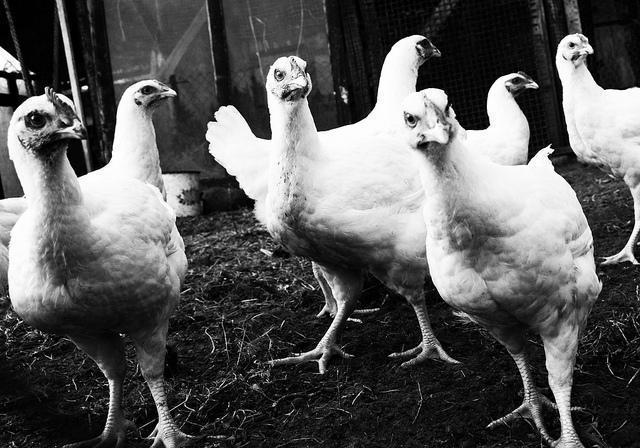What type of animal is in the image?
Pick the right solution, then justify: 'Answer: answer
Rationale: rationale.'
Options: Chickens, ducks, cows, dogs. Answer: chickens.
Rationale: The animal is a chicken. 